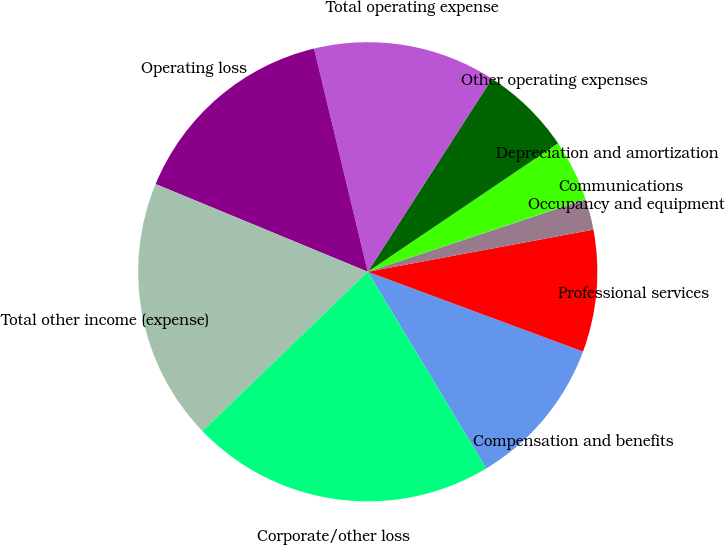<chart> <loc_0><loc_0><loc_500><loc_500><pie_chart><fcel>Compensation and benefits<fcel>Professional services<fcel>Occupancy and equipment<fcel>Communications<fcel>Depreciation and amortization<fcel>Other operating expenses<fcel>Total operating expense<fcel>Operating loss<fcel>Total other income (expense)<fcel>Corporate/other loss<nl><fcel>10.72%<fcel>8.59%<fcel>2.17%<fcel>0.03%<fcel>4.31%<fcel>6.45%<fcel>12.86%<fcel>15.0%<fcel>18.45%<fcel>21.42%<nl></chart> 